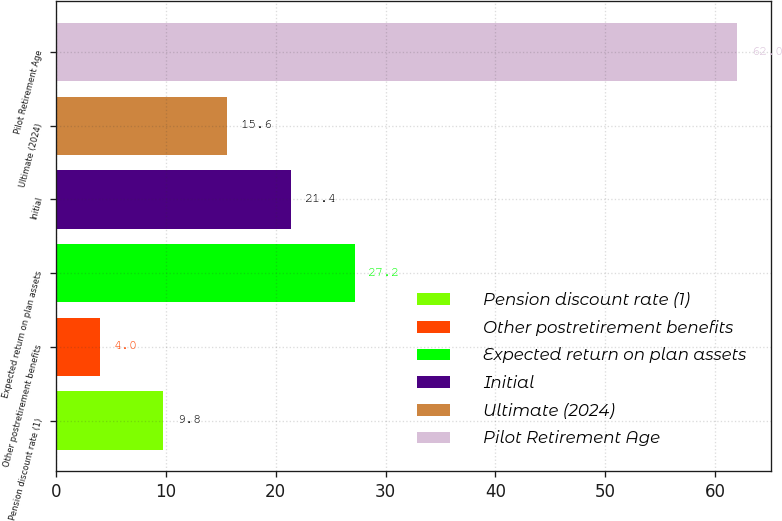<chart> <loc_0><loc_0><loc_500><loc_500><bar_chart><fcel>Pension discount rate (1)<fcel>Other postretirement benefits<fcel>Expected return on plan assets<fcel>Initial<fcel>Ultimate (2024)<fcel>Pilot Retirement Age<nl><fcel>9.8<fcel>4<fcel>27.2<fcel>21.4<fcel>15.6<fcel>62<nl></chart> 